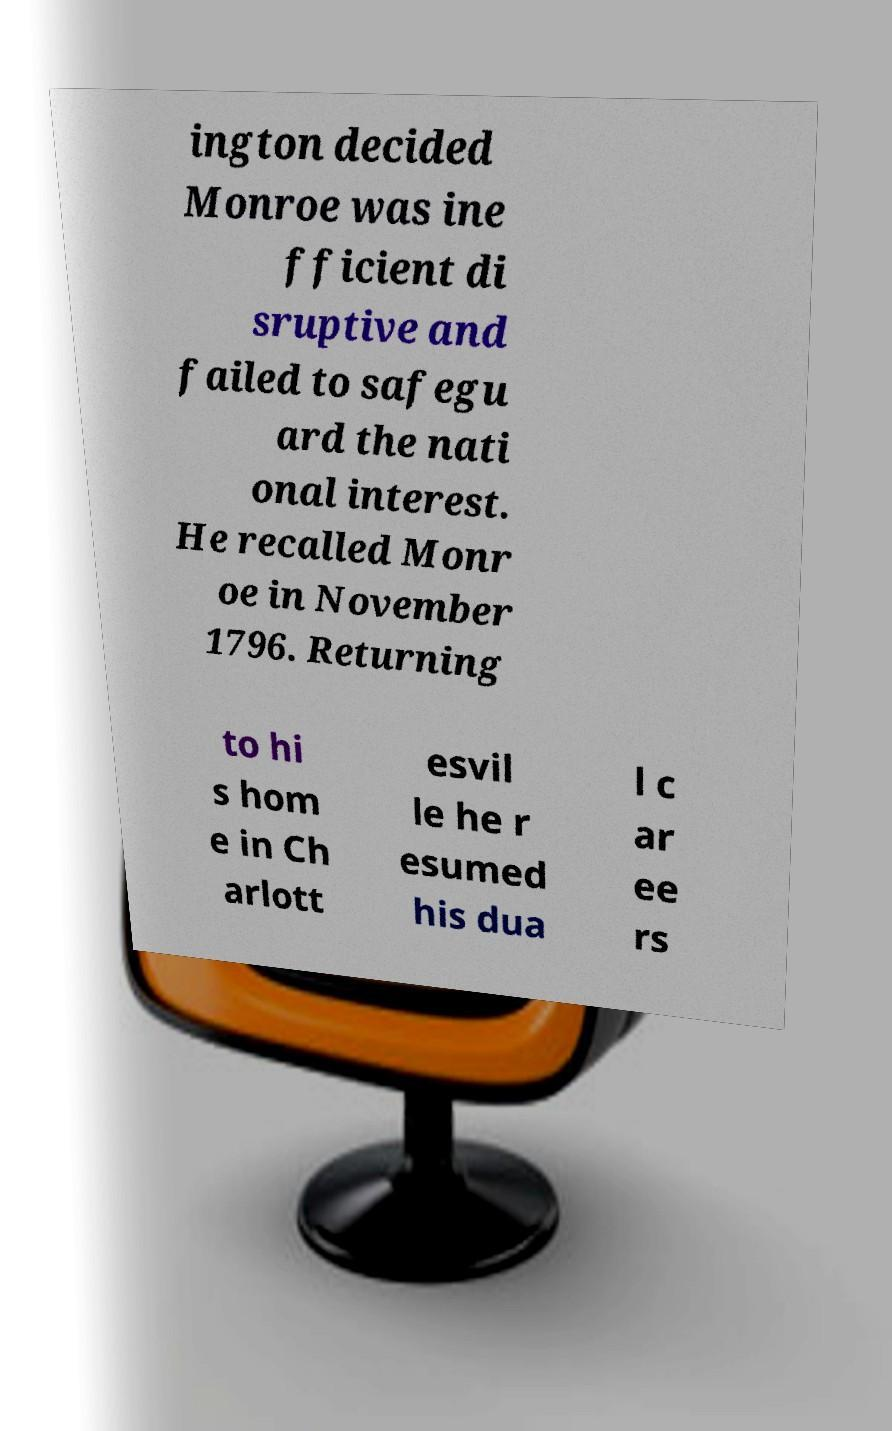Could you extract and type out the text from this image? ington decided Monroe was ine fficient di sruptive and failed to safegu ard the nati onal interest. He recalled Monr oe in November 1796. Returning to hi s hom e in Ch arlott esvil le he r esumed his dua l c ar ee rs 